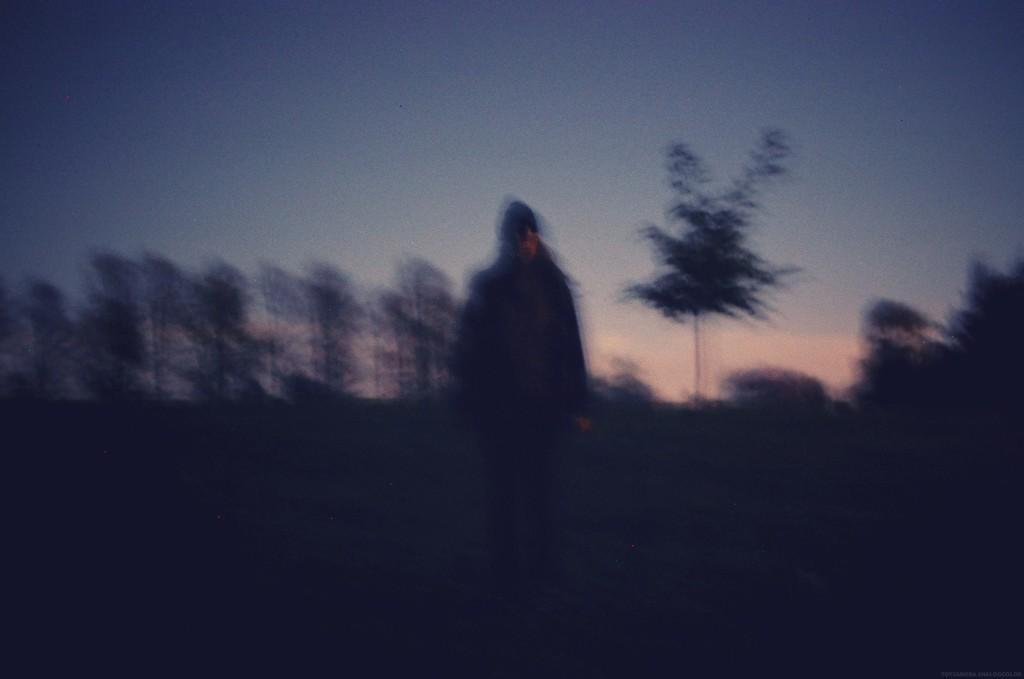Who or what is the main subject in the image? There is a person in the middle of the image. What can be seen in the background of the image? There are trees in the background of the image. What type of design can be seen on the person's clothing in the image? There is no information about the person's clothing or any design on it in the provided facts. --- Facts: 1. There is a car in the image. 2. The car is red. 3. The car has four wheels. 4. There is a road in the image. Absurd Topics: unicorn, rainbow, clouds Conversation: What is the main subject in the image? There is a car in the image. What color is the car? The car is red. How many wheels does the car have? The car has four wheels. What can be seen in the background of the image? There is a road in the background of the image. Reasoning: Let's think step by step in order to produce the conversation. We start by identifying the main subject of the image, which is the car. Next, we describe specific features of the car, such as the color and the number of wheels. Then, we observe the actions of the car, noting that it is on a road. Finally, we describe the background of the image, which features a road. Absurd Question/Answer: What type of unicorn can be seen grazing on the side of the road in the image? There is no unicorn present in the image. --- Facts: 1. There is a person in the image. 2. The person is wearing a hat. 3. The person is holding a book. 4. There is a table in the image. 5. The table has a vase with flowers on it. Absurd Topics: dinosaur, volcano, lava Conversation: Who or what is the main subject in the image? There is a person in the image. What is the person wearing on their head? The person is wearing a hat. What is the person holding in their hands? The person is holding a book. What can be seen on the table in the image? There is a vase with flowers on the table in the image. Reasoning: Let's think step by step in order to produce the conversation. We start by identifying the main subject of the image, which is the person. Next, we describe specific features of the person, such as the hat they are wearing. Then, we observe the actions of the person, noting that they are holding a book. Finally, we describe the table and its contents, which features a vase with flowers on it. Absurd Question/Answer: Can you see a dinosaur erupting lava from a volcano in the image? There is no dinosaur, volcano, or lava 